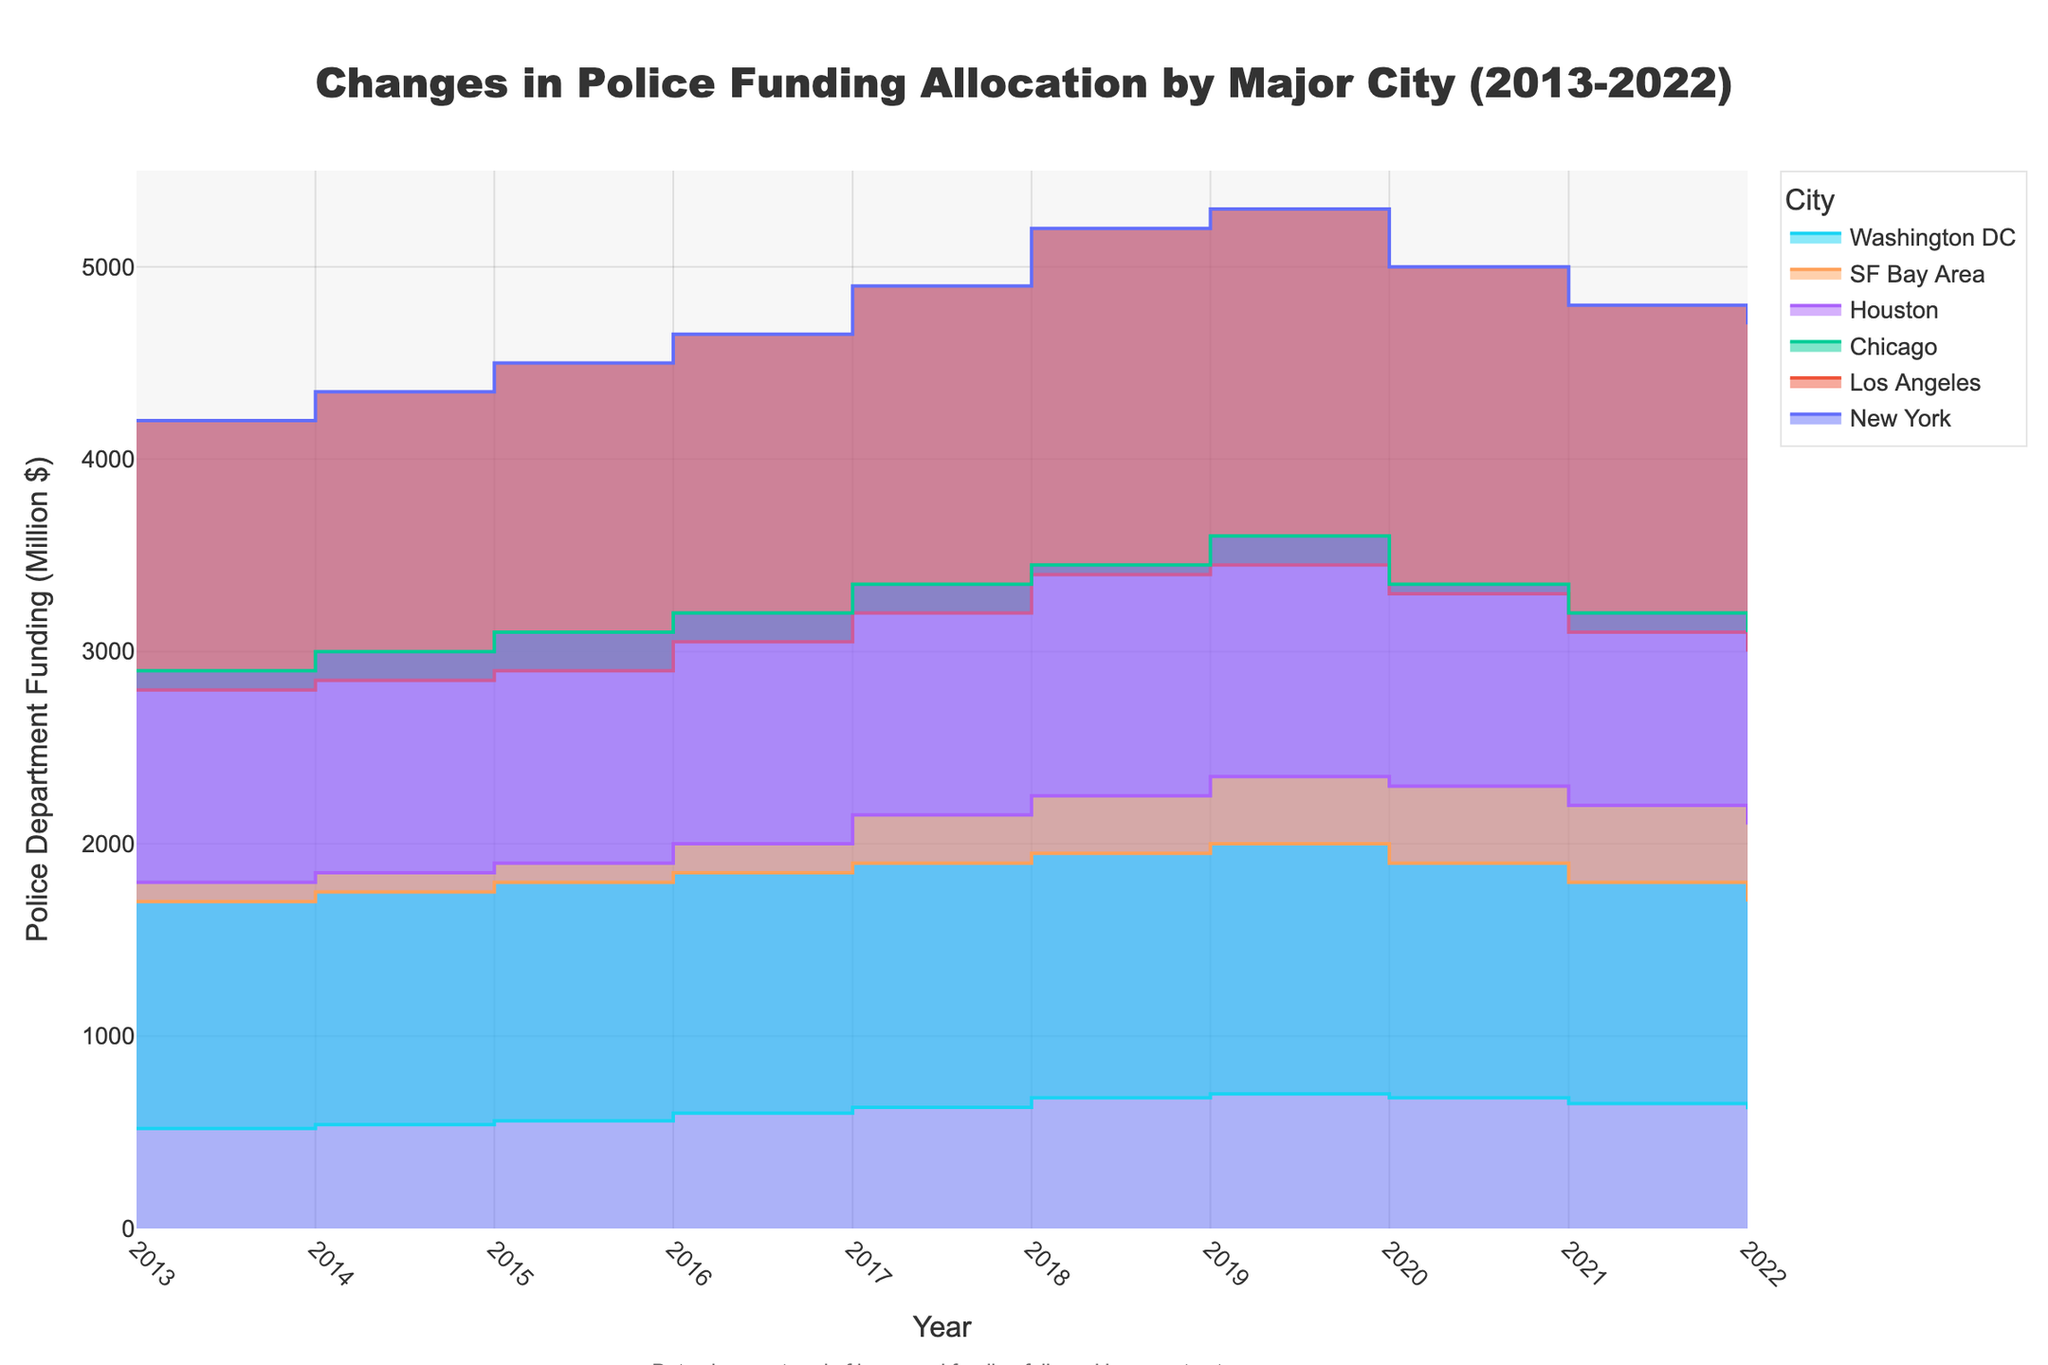What is the title of the chart? The title of the chart is located at the top center of the figure and provides a brief description of the data being presented.
Answer: Changes in Police Funding Allocation by Major City (2013-2022) What year did New York reach its peak police funding, and what was the amount? By carefully examining the step-like representations for New York, it is evident that the peak occurred in 2019 with increased funding in earlier years and decreased funding afterward. The peak amount can be seen as the highest step value in 2019.
Answer: 2019, $5300 million How does the funding trend in San Francisco (SF Bay Area) compare after 2019? By observing the step areas for San Francisco, we see a noticeable decline in funding after 2019. Funding decreases stepwise from 2020 to 2022.
Answer: Declining Which city experienced the most significant funding cuts after their peak year? To answer this, find the peak funding year for each city and then measure the largest drop by comparing the peak funding with subsequent years. By calculation, New York drops from $5300 million in 2019 to $4700 million by 2022, which is a cut of $600 million.
Answer: New York What is the total police funding for Houston over the ten years? Summing the annual funding values for Houston from 2013 to 2022. The values are $1800M, $1850M, $1900M, $2000M, $2150M, $2250M, $2350M, $2300M, $2200M, and $2100M. The total = 1800 + 1850 + 1900 + 2000 + 2150 + 2250 + 2350 + 2300 + 2200 + 2100.
Answer: $20900 million In which years did Chicago's police department funding decrease, and by how much? Analyzing the line segments for Chicago helps identify years when funding dropped. These instances are between 2019 to 2020 (from $3600M to $3350M), 2020 to 2021 (from $3350M to $3200M), and 2021 to 2022 (from $3200M to $3100M). The precise decreases are $250M (2019-2020), $150M (2020-2021), and $100M (2021-2022).
Answer: 2019 to 2020 ($250M), 2020 to 2021 ($150M), 2021 to 2022 ($100M) Which city had the highest increase in police funding from 2013 to 2019? Calculate the increment for each city from 2013 to 2019. New York increased by $5300M - $4200M (=$1100M), Los Angeles by $3450M - $2800M (=$650M), Chicago by $3600M - $2900M (=$700M), Houston by $2350M - $1800M (=$550M), SF Bay Area by $2000M - $1700M (=$300M), and Washington DC by $700M - $520M (=$180M).
Answer: New York ($1100M) How consistent was Washington DC's police funding increase over the given period? By examining the year-to-year steps for Washington DC, it is evident that funding increases steadily until 2019, with a few decreases post-2019. This trend indicates an overall growth but with recent declines.
Answer: Steady increase until 2019, then declining 